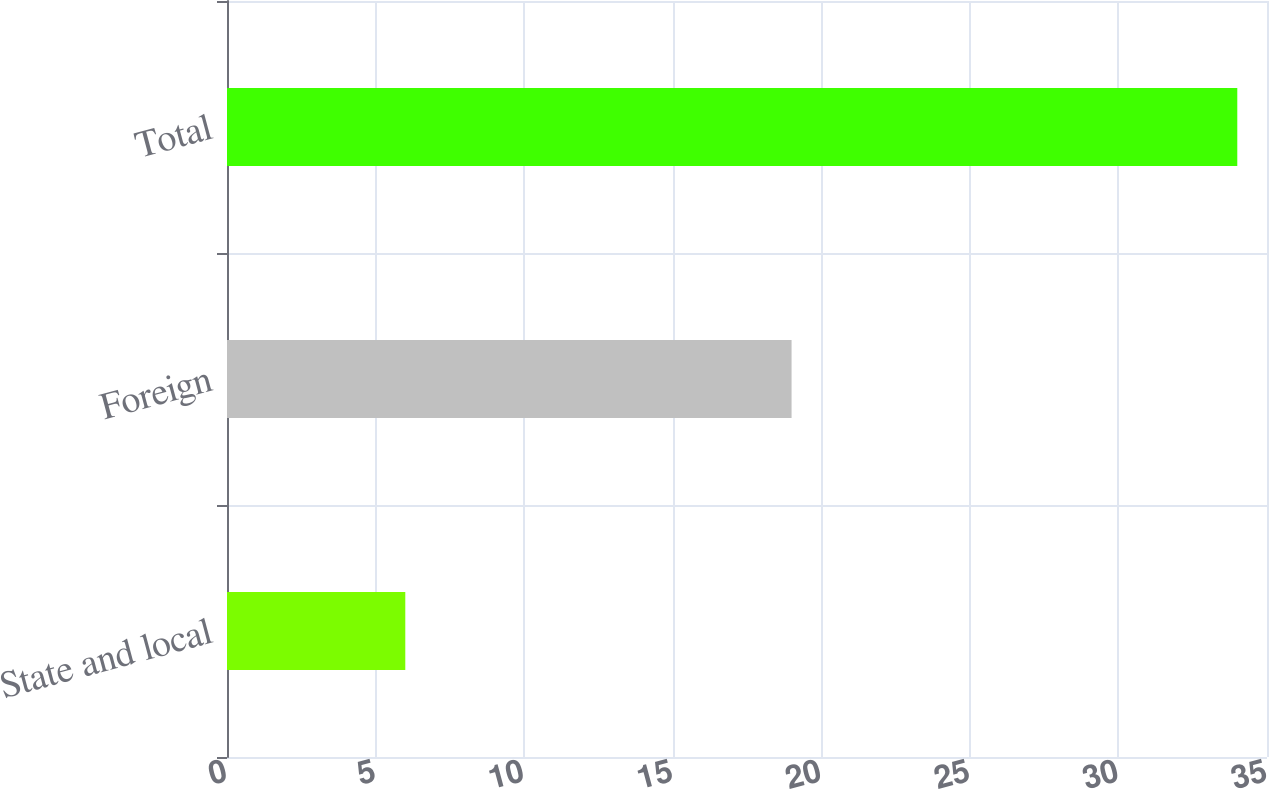Convert chart to OTSL. <chart><loc_0><loc_0><loc_500><loc_500><bar_chart><fcel>State and local<fcel>Foreign<fcel>Total<nl><fcel>6<fcel>19<fcel>34<nl></chart> 